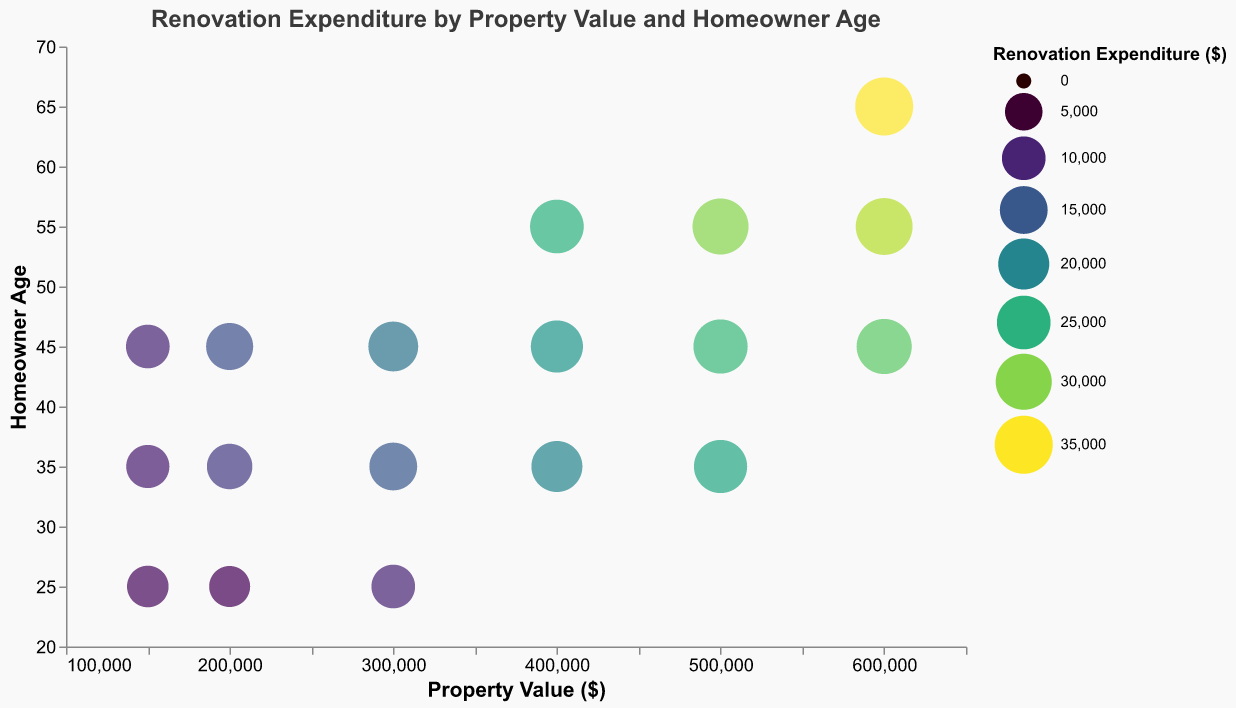What is the title of the figure? The title of the figure is located at the top and it reads "Renovation Expenditure by Property Value and Homeowner Age".
Answer: Renovation Expenditure by Property Value and Homeowner Age How many distinct property values are shown in the figure? By looking at the x-axis, we can see there are property values at 150,000, 200,000, 300,000, 400,000, 500,000, and 600,000. Count of property values is 6.
Answer: 6 Which homeowner age group has the highest renovation expenditure? By observing the bubble sizes and their labels, the largest bubble corresponds to a homeowner age of 65 with a renovation expenditure of 35,000.
Answer: 65 What is the renovation expenditure for a property value of $400,000 and homeowner age of 35? By locating the bubble where Property Value is 400,000 and Homeowner Age is 35, the renovation expenditure for this data point is 20,000.
Answer: 20,000 Is there a pattern between property value and renovation expenditure? Higher property values generally correspond to higher renovation expenditures, as seen by the larger bubbles for higher property values.
Answer: Yes, higher property values generally have higher renovation expenditures What is the average renovation expenditure for homeowners aged 45? First, get the renovation expenditures for homeowners aged 45: 10,000, 14,000, 18,000, 22,000, 26,000, and 28,000. Sum these values: 10,000 + 14,000 + 18,000 + 22,000 + 26,000 + 28,000 = 118,000. Divide by the number of data points (6): 118,000 / 6 = 19,667.
Answer: 19,667 Do younger homeowners (under 35) spend less on renovations compared to older homeowners (55 and above)? By comparing the bubble sizes, younger homeowners (aged 25 and 35) generally have lower renovation expenditures compared to older homeowners (aged 55 and 65). Younger homeowners have expenditures ranging from 7,500 to 24,000, while older homeowners have expenditures ranging from 25,000 to 35,000.
Answer: Yes Which property value and homeowner age combination has the smallest renovation expenditure? The smallest bubble on the chart corresponds to a property value of 200,000 and a homeowner age of 25 with an expenditure of 7,500.
Answer: 200,000 and 25 How does renovation expenditure vary across different ages for a property value of $300,000? For the property value of 300,000, the renovation expenditures for ages 25, 35, and 45 are 10,000, 15,000, and 18,000, respectively. The expenditure increases with the homeowner's age.
Answer: It increases with age Are there any outliers in the renovation expenditure data? Outliers can be detected by identifying bubbles that are significantly larger or smaller than others. The maximum expenditure of 35,000 by a 65-year-old homeowner appears as an outlier, as it is much larger than other values in the dataset.
Answer: Yes, expenditure of 35,000 by a 65-year-old homeowner appears as an outlier 